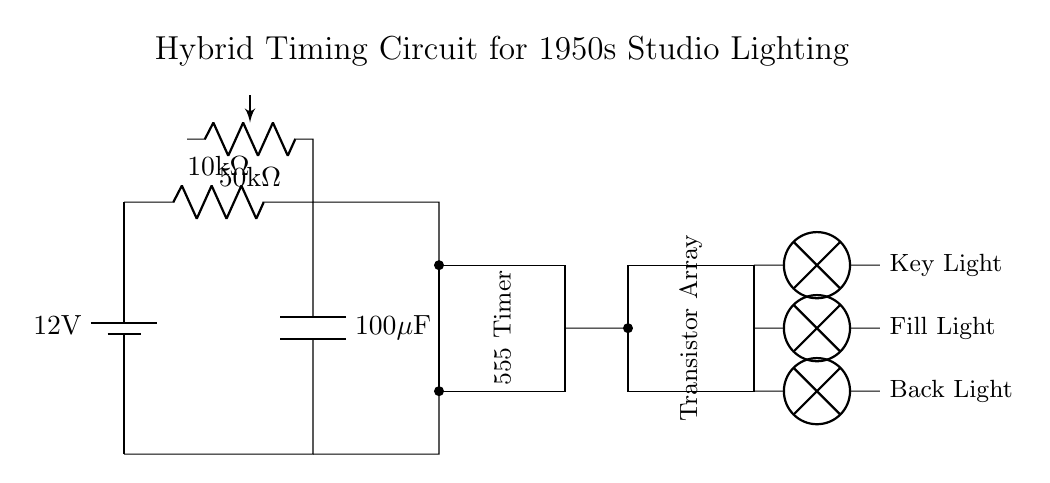What is the main voltage source in this circuit? The circuit has a 12V battery as the main power source, indicated at the top left.
Answer: 12V What type of capacitor is used in this circuit? A capacitor labeled as 100 microfarads can be found connected in series with a resistor.
Answer: 100 microfarads How many lights are controlled by the circuit? The circuit is designed to control three lights: a key light, a fill light, and a back light.
Answer: Three lights What component is used to adjust the timing of the lights? A potentiometer labeled as 50 kilohms is present, allowing for timing adjustments.
Answer: 50 kilohms What is the purpose of the 555 Timer in this circuit? The 555 Timer is utilized for generating precise timing intervals to control the sequential lighting.
Answer: Timing intervals Which component provides the output for the lights? A transistor array is used to switch the output to the lights based on the timer control.
Answer: Transistor array 